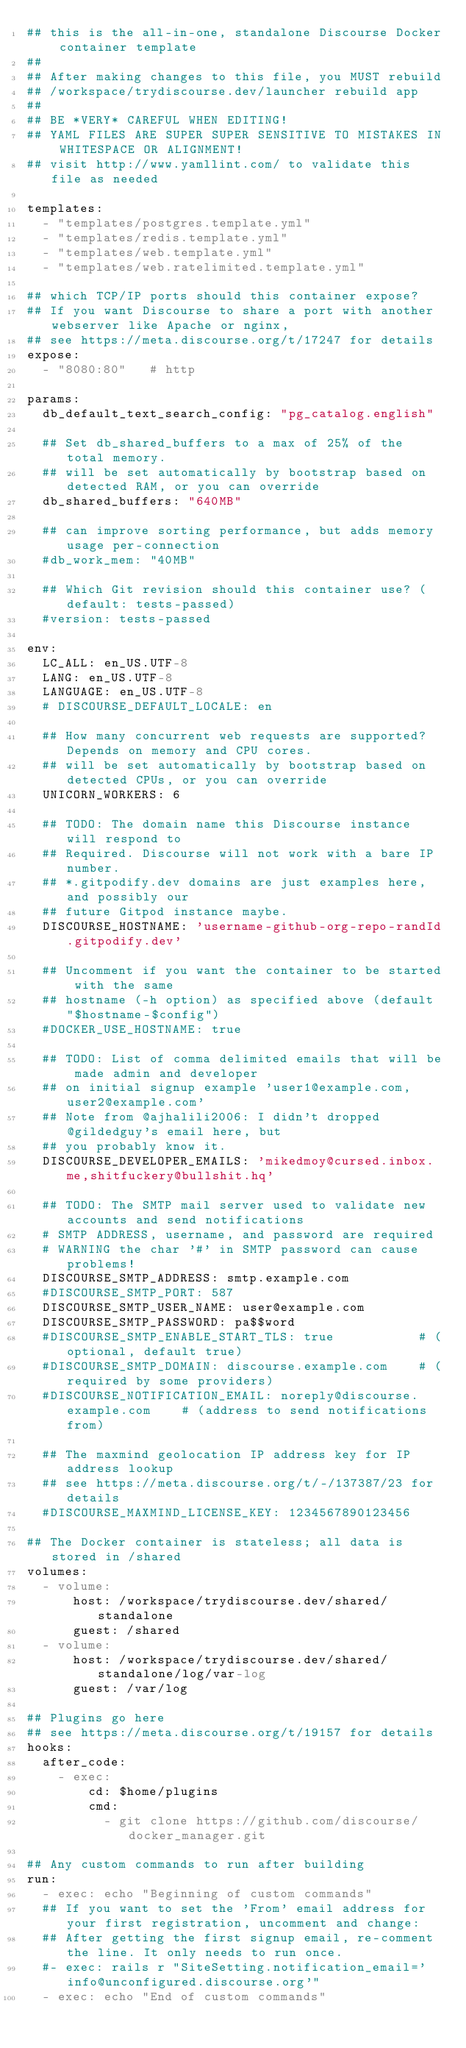Convert code to text. <code><loc_0><loc_0><loc_500><loc_500><_YAML_>## this is the all-in-one, standalone Discourse Docker container template
##
## After making changes to this file, you MUST rebuild
## /workspace/trydiscourse.dev/launcher rebuild app
##
## BE *VERY* CAREFUL WHEN EDITING!
## YAML FILES ARE SUPER SUPER SENSITIVE TO MISTAKES IN WHITESPACE OR ALIGNMENT!
## visit http://www.yamllint.com/ to validate this file as needed

templates:
  - "templates/postgres.template.yml"
  - "templates/redis.template.yml"
  - "templates/web.template.yml"
  - "templates/web.ratelimited.template.yml"

## which TCP/IP ports should this container expose?
## If you want Discourse to share a port with another webserver like Apache or nginx,
## see https://meta.discourse.org/t/17247 for details
expose:
  - "8080:80"   # http

params:
  db_default_text_search_config: "pg_catalog.english"

  ## Set db_shared_buffers to a max of 25% of the total memory.
  ## will be set automatically by bootstrap based on detected RAM, or you can override
  db_shared_buffers: "640MB"

  ## can improve sorting performance, but adds memory usage per-connection
  #db_work_mem: "40MB"

  ## Which Git revision should this container use? (default: tests-passed)
  #version: tests-passed

env:
  LC_ALL: en_US.UTF-8
  LANG: en_US.UTF-8
  LANGUAGE: en_US.UTF-8
  # DISCOURSE_DEFAULT_LOCALE: en

  ## How many concurrent web requests are supported? Depends on memory and CPU cores.
  ## will be set automatically by bootstrap based on detected CPUs, or you can override
  UNICORN_WORKERS: 6

  ## TODO: The domain name this Discourse instance will respond to
  ## Required. Discourse will not work with a bare IP number.
  ## *.gitpodify.dev domains are just examples here, and possibly our
  ## future Gitpod instance maybe.
  DISCOURSE_HOSTNAME: 'username-github-org-repo-randId.gitpodify.dev'

  ## Uncomment if you want the container to be started with the same
  ## hostname (-h option) as specified above (default "$hostname-$config")
  #DOCKER_USE_HOSTNAME: true

  ## TODO: List of comma delimited emails that will be made admin and developer
  ## on initial signup example 'user1@example.com,user2@example.com'
  ## Note from @ajhalili2006: I didn't dropped @gildedguy's email here, but
  ## you probably know it.
  DISCOURSE_DEVELOPER_EMAILS: 'mikedmoy@cursed.inbox.me,shitfuckery@bullshit.hq'

  ## TODO: The SMTP mail server used to validate new accounts and send notifications
  # SMTP ADDRESS, username, and password are required
  # WARNING the char '#' in SMTP password can cause problems!
  DISCOURSE_SMTP_ADDRESS: smtp.example.com
  #DISCOURSE_SMTP_PORT: 587
  DISCOURSE_SMTP_USER_NAME: user@example.com
  DISCOURSE_SMTP_PASSWORD: pa$$word
  #DISCOURSE_SMTP_ENABLE_START_TLS: true           # (optional, default true)
  #DISCOURSE_SMTP_DOMAIN: discourse.example.com    # (required by some providers)
  #DISCOURSE_NOTIFICATION_EMAIL: noreply@discourse.example.com    # (address to send notifications from)
  
  ## The maxmind geolocation IP address key for IP address lookup
  ## see https://meta.discourse.org/t/-/137387/23 for details
  #DISCOURSE_MAXMIND_LICENSE_KEY: 1234567890123456

## The Docker container is stateless; all data is stored in /shared
volumes:
  - volume:
      host: /workspace/trydiscourse.dev/shared/standalone
      guest: /shared
  - volume:
      host: /workspace/trydiscourse.dev/shared/standalone/log/var-log
      guest: /var/log

## Plugins go here
## see https://meta.discourse.org/t/19157 for details
hooks:
  after_code:
    - exec:
        cd: $home/plugins
        cmd:
          - git clone https://github.com/discourse/docker_manager.git

## Any custom commands to run after building
run:
  - exec: echo "Beginning of custom commands"
  ## If you want to set the 'From' email address for your first registration, uncomment and change:
  ## After getting the first signup email, re-comment the line. It only needs to run once.
  #- exec: rails r "SiteSetting.notification_email='info@unconfigured.discourse.org'"
  - exec: echo "End of custom commands"
</code> 